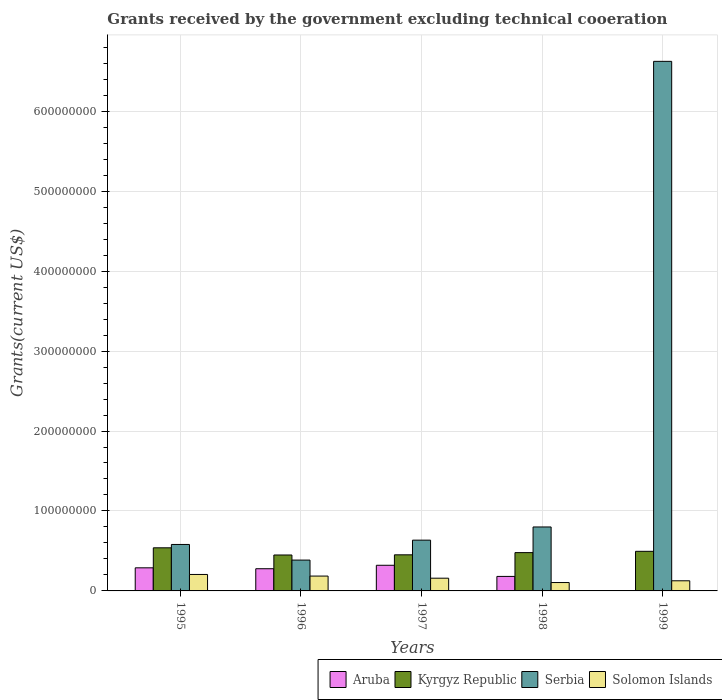How many groups of bars are there?
Offer a terse response. 5. How many bars are there on the 5th tick from the right?
Keep it short and to the point. 4. What is the total grants received by the government in Kyrgyz Republic in 1996?
Your answer should be very brief. 4.49e+07. Across all years, what is the maximum total grants received by the government in Serbia?
Keep it short and to the point. 6.62e+08. Across all years, what is the minimum total grants received by the government in Serbia?
Give a very brief answer. 3.86e+07. In which year was the total grants received by the government in Kyrgyz Republic minimum?
Your answer should be compact. 1996. What is the total total grants received by the government in Serbia in the graph?
Offer a very short reply. 9.03e+08. What is the difference between the total grants received by the government in Solomon Islands in 1995 and that in 1998?
Your answer should be very brief. 1.01e+07. What is the difference between the total grants received by the government in Serbia in 1998 and the total grants received by the government in Kyrgyz Republic in 1999?
Your response must be concise. 3.04e+07. What is the average total grants received by the government in Serbia per year?
Provide a short and direct response. 1.81e+08. In the year 1995, what is the difference between the total grants received by the government in Kyrgyz Republic and total grants received by the government in Solomon Islands?
Your answer should be very brief. 3.33e+07. In how many years, is the total grants received by the government in Aruba greater than 60000000 US$?
Ensure brevity in your answer.  0. What is the ratio of the total grants received by the government in Solomon Islands in 1995 to that in 1996?
Give a very brief answer. 1.11. Is the total grants received by the government in Serbia in 1997 less than that in 1999?
Provide a short and direct response. Yes. Is the difference between the total grants received by the government in Kyrgyz Republic in 1995 and 1996 greater than the difference between the total grants received by the government in Solomon Islands in 1995 and 1996?
Ensure brevity in your answer.  Yes. What is the difference between the highest and the second highest total grants received by the government in Kyrgyz Republic?
Provide a short and direct response. 4.38e+06. What is the difference between the highest and the lowest total grants received by the government in Solomon Islands?
Your response must be concise. 1.01e+07. In how many years, is the total grants received by the government in Solomon Islands greater than the average total grants received by the government in Solomon Islands taken over all years?
Your answer should be very brief. 3. What does the 1st bar from the left in 1998 represents?
Your response must be concise. Aruba. What does the 1st bar from the right in 1996 represents?
Keep it short and to the point. Solomon Islands. What is the difference between two consecutive major ticks on the Y-axis?
Provide a short and direct response. 1.00e+08. How many legend labels are there?
Offer a very short reply. 4. How are the legend labels stacked?
Ensure brevity in your answer.  Horizontal. What is the title of the graph?
Ensure brevity in your answer.  Grants received by the government excluding technical cooeration. What is the label or title of the Y-axis?
Keep it short and to the point. Grants(current US$). What is the Grants(current US$) of Aruba in 1995?
Provide a succinct answer. 2.89e+07. What is the Grants(current US$) of Kyrgyz Republic in 1995?
Provide a short and direct response. 5.39e+07. What is the Grants(current US$) in Serbia in 1995?
Your answer should be very brief. 5.81e+07. What is the Grants(current US$) of Solomon Islands in 1995?
Offer a very short reply. 2.06e+07. What is the Grants(current US$) in Aruba in 1996?
Offer a terse response. 2.78e+07. What is the Grants(current US$) of Kyrgyz Republic in 1996?
Offer a terse response. 4.49e+07. What is the Grants(current US$) in Serbia in 1996?
Keep it short and to the point. 3.86e+07. What is the Grants(current US$) of Solomon Islands in 1996?
Keep it short and to the point. 1.86e+07. What is the Grants(current US$) of Aruba in 1997?
Keep it short and to the point. 3.21e+07. What is the Grants(current US$) in Kyrgyz Republic in 1997?
Provide a short and direct response. 4.52e+07. What is the Grants(current US$) of Serbia in 1997?
Ensure brevity in your answer.  6.35e+07. What is the Grants(current US$) of Solomon Islands in 1997?
Provide a succinct answer. 1.59e+07. What is the Grants(current US$) of Aruba in 1998?
Offer a terse response. 1.81e+07. What is the Grants(current US$) in Kyrgyz Republic in 1998?
Keep it short and to the point. 4.79e+07. What is the Grants(current US$) in Serbia in 1998?
Offer a terse response. 8.00e+07. What is the Grants(current US$) in Solomon Islands in 1998?
Provide a succinct answer. 1.05e+07. What is the Grants(current US$) in Kyrgyz Republic in 1999?
Your answer should be very brief. 4.95e+07. What is the Grants(current US$) of Serbia in 1999?
Your answer should be compact. 6.62e+08. What is the Grants(current US$) in Solomon Islands in 1999?
Provide a short and direct response. 1.27e+07. Across all years, what is the maximum Grants(current US$) of Aruba?
Your answer should be compact. 3.21e+07. Across all years, what is the maximum Grants(current US$) of Kyrgyz Republic?
Make the answer very short. 5.39e+07. Across all years, what is the maximum Grants(current US$) of Serbia?
Your answer should be very brief. 6.62e+08. Across all years, what is the maximum Grants(current US$) of Solomon Islands?
Your answer should be very brief. 2.06e+07. Across all years, what is the minimum Grants(current US$) in Aruba?
Your answer should be very brief. 4.00e+04. Across all years, what is the minimum Grants(current US$) of Kyrgyz Republic?
Provide a short and direct response. 4.49e+07. Across all years, what is the minimum Grants(current US$) of Serbia?
Provide a succinct answer. 3.86e+07. Across all years, what is the minimum Grants(current US$) of Solomon Islands?
Give a very brief answer. 1.05e+07. What is the total Grants(current US$) of Aruba in the graph?
Your answer should be very brief. 1.07e+08. What is the total Grants(current US$) in Kyrgyz Republic in the graph?
Your answer should be very brief. 2.41e+08. What is the total Grants(current US$) in Serbia in the graph?
Give a very brief answer. 9.03e+08. What is the total Grants(current US$) in Solomon Islands in the graph?
Your response must be concise. 7.82e+07. What is the difference between the Grants(current US$) in Aruba in 1995 and that in 1996?
Your response must be concise. 1.14e+06. What is the difference between the Grants(current US$) of Kyrgyz Republic in 1995 and that in 1996?
Provide a succinct answer. 8.99e+06. What is the difference between the Grants(current US$) of Serbia in 1995 and that in 1996?
Your answer should be compact. 1.95e+07. What is the difference between the Grants(current US$) of Solomon Islands in 1995 and that in 1996?
Your response must be concise. 2.02e+06. What is the difference between the Grants(current US$) of Aruba in 1995 and that in 1997?
Provide a short and direct response. -3.18e+06. What is the difference between the Grants(current US$) in Kyrgyz Republic in 1995 and that in 1997?
Offer a terse response. 8.76e+06. What is the difference between the Grants(current US$) in Serbia in 1995 and that in 1997?
Offer a very short reply. -5.40e+06. What is the difference between the Grants(current US$) in Solomon Islands in 1995 and that in 1997?
Ensure brevity in your answer.  4.67e+06. What is the difference between the Grants(current US$) in Aruba in 1995 and that in 1998?
Keep it short and to the point. 1.08e+07. What is the difference between the Grants(current US$) in Kyrgyz Republic in 1995 and that in 1998?
Provide a short and direct response. 6.01e+06. What is the difference between the Grants(current US$) of Serbia in 1995 and that in 1998?
Keep it short and to the point. -2.19e+07. What is the difference between the Grants(current US$) of Solomon Islands in 1995 and that in 1998?
Ensure brevity in your answer.  1.01e+07. What is the difference between the Grants(current US$) of Aruba in 1995 and that in 1999?
Provide a succinct answer. 2.89e+07. What is the difference between the Grants(current US$) of Kyrgyz Republic in 1995 and that in 1999?
Keep it short and to the point. 4.38e+06. What is the difference between the Grants(current US$) in Serbia in 1995 and that in 1999?
Your response must be concise. -6.04e+08. What is the difference between the Grants(current US$) in Solomon Islands in 1995 and that in 1999?
Your response must be concise. 7.91e+06. What is the difference between the Grants(current US$) in Aruba in 1996 and that in 1997?
Provide a succinct answer. -4.32e+06. What is the difference between the Grants(current US$) in Serbia in 1996 and that in 1997?
Give a very brief answer. -2.49e+07. What is the difference between the Grants(current US$) of Solomon Islands in 1996 and that in 1997?
Your response must be concise. 2.65e+06. What is the difference between the Grants(current US$) of Aruba in 1996 and that in 1998?
Give a very brief answer. 9.62e+06. What is the difference between the Grants(current US$) in Kyrgyz Republic in 1996 and that in 1998?
Your answer should be compact. -2.98e+06. What is the difference between the Grants(current US$) of Serbia in 1996 and that in 1998?
Offer a very short reply. -4.14e+07. What is the difference between the Grants(current US$) of Solomon Islands in 1996 and that in 1998?
Keep it short and to the point. 8.08e+06. What is the difference between the Grants(current US$) in Aruba in 1996 and that in 1999?
Ensure brevity in your answer.  2.77e+07. What is the difference between the Grants(current US$) of Kyrgyz Republic in 1996 and that in 1999?
Offer a terse response. -4.61e+06. What is the difference between the Grants(current US$) in Serbia in 1996 and that in 1999?
Make the answer very short. -6.24e+08. What is the difference between the Grants(current US$) of Solomon Islands in 1996 and that in 1999?
Your answer should be compact. 5.89e+06. What is the difference between the Grants(current US$) of Aruba in 1997 and that in 1998?
Your response must be concise. 1.39e+07. What is the difference between the Grants(current US$) in Kyrgyz Republic in 1997 and that in 1998?
Ensure brevity in your answer.  -2.75e+06. What is the difference between the Grants(current US$) of Serbia in 1997 and that in 1998?
Your response must be concise. -1.65e+07. What is the difference between the Grants(current US$) of Solomon Islands in 1997 and that in 1998?
Your answer should be compact. 5.43e+06. What is the difference between the Grants(current US$) in Aruba in 1997 and that in 1999?
Your response must be concise. 3.20e+07. What is the difference between the Grants(current US$) in Kyrgyz Republic in 1997 and that in 1999?
Give a very brief answer. -4.38e+06. What is the difference between the Grants(current US$) of Serbia in 1997 and that in 1999?
Your answer should be compact. -5.99e+08. What is the difference between the Grants(current US$) in Solomon Islands in 1997 and that in 1999?
Make the answer very short. 3.24e+06. What is the difference between the Grants(current US$) of Aruba in 1998 and that in 1999?
Your answer should be compact. 1.81e+07. What is the difference between the Grants(current US$) in Kyrgyz Republic in 1998 and that in 1999?
Your answer should be very brief. -1.63e+06. What is the difference between the Grants(current US$) of Serbia in 1998 and that in 1999?
Provide a short and direct response. -5.82e+08. What is the difference between the Grants(current US$) of Solomon Islands in 1998 and that in 1999?
Provide a short and direct response. -2.19e+06. What is the difference between the Grants(current US$) of Aruba in 1995 and the Grants(current US$) of Kyrgyz Republic in 1996?
Give a very brief answer. -1.60e+07. What is the difference between the Grants(current US$) in Aruba in 1995 and the Grants(current US$) in Serbia in 1996?
Ensure brevity in your answer.  -9.67e+06. What is the difference between the Grants(current US$) in Aruba in 1995 and the Grants(current US$) in Solomon Islands in 1996?
Your answer should be very brief. 1.03e+07. What is the difference between the Grants(current US$) of Kyrgyz Republic in 1995 and the Grants(current US$) of Serbia in 1996?
Give a very brief answer. 1.54e+07. What is the difference between the Grants(current US$) in Kyrgyz Republic in 1995 and the Grants(current US$) in Solomon Islands in 1996?
Provide a short and direct response. 3.54e+07. What is the difference between the Grants(current US$) of Serbia in 1995 and the Grants(current US$) of Solomon Islands in 1996?
Your answer should be very brief. 3.95e+07. What is the difference between the Grants(current US$) of Aruba in 1995 and the Grants(current US$) of Kyrgyz Republic in 1997?
Make the answer very short. -1.63e+07. What is the difference between the Grants(current US$) in Aruba in 1995 and the Grants(current US$) in Serbia in 1997?
Offer a very short reply. -3.46e+07. What is the difference between the Grants(current US$) of Aruba in 1995 and the Grants(current US$) of Solomon Islands in 1997?
Offer a very short reply. 1.30e+07. What is the difference between the Grants(current US$) of Kyrgyz Republic in 1995 and the Grants(current US$) of Serbia in 1997?
Give a very brief answer. -9.58e+06. What is the difference between the Grants(current US$) of Kyrgyz Republic in 1995 and the Grants(current US$) of Solomon Islands in 1997?
Offer a very short reply. 3.80e+07. What is the difference between the Grants(current US$) of Serbia in 1995 and the Grants(current US$) of Solomon Islands in 1997?
Ensure brevity in your answer.  4.22e+07. What is the difference between the Grants(current US$) of Aruba in 1995 and the Grants(current US$) of Kyrgyz Republic in 1998?
Your answer should be compact. -1.90e+07. What is the difference between the Grants(current US$) in Aruba in 1995 and the Grants(current US$) in Serbia in 1998?
Ensure brevity in your answer.  -5.11e+07. What is the difference between the Grants(current US$) of Aruba in 1995 and the Grants(current US$) of Solomon Islands in 1998?
Offer a very short reply. 1.84e+07. What is the difference between the Grants(current US$) in Kyrgyz Republic in 1995 and the Grants(current US$) in Serbia in 1998?
Make the answer very short. -2.61e+07. What is the difference between the Grants(current US$) in Kyrgyz Republic in 1995 and the Grants(current US$) in Solomon Islands in 1998?
Offer a very short reply. 4.34e+07. What is the difference between the Grants(current US$) in Serbia in 1995 and the Grants(current US$) in Solomon Islands in 1998?
Make the answer very short. 4.76e+07. What is the difference between the Grants(current US$) in Aruba in 1995 and the Grants(current US$) in Kyrgyz Republic in 1999?
Your answer should be very brief. -2.06e+07. What is the difference between the Grants(current US$) in Aruba in 1995 and the Grants(current US$) in Serbia in 1999?
Provide a short and direct response. -6.33e+08. What is the difference between the Grants(current US$) in Aruba in 1995 and the Grants(current US$) in Solomon Islands in 1999?
Ensure brevity in your answer.  1.62e+07. What is the difference between the Grants(current US$) in Kyrgyz Republic in 1995 and the Grants(current US$) in Serbia in 1999?
Provide a succinct answer. -6.08e+08. What is the difference between the Grants(current US$) of Kyrgyz Republic in 1995 and the Grants(current US$) of Solomon Islands in 1999?
Your answer should be compact. 4.12e+07. What is the difference between the Grants(current US$) in Serbia in 1995 and the Grants(current US$) in Solomon Islands in 1999?
Give a very brief answer. 4.54e+07. What is the difference between the Grants(current US$) of Aruba in 1996 and the Grants(current US$) of Kyrgyz Republic in 1997?
Provide a short and direct response. -1.74e+07. What is the difference between the Grants(current US$) in Aruba in 1996 and the Grants(current US$) in Serbia in 1997?
Your answer should be very brief. -3.57e+07. What is the difference between the Grants(current US$) of Aruba in 1996 and the Grants(current US$) of Solomon Islands in 1997?
Your answer should be very brief. 1.18e+07. What is the difference between the Grants(current US$) of Kyrgyz Republic in 1996 and the Grants(current US$) of Serbia in 1997?
Offer a very short reply. -1.86e+07. What is the difference between the Grants(current US$) in Kyrgyz Republic in 1996 and the Grants(current US$) in Solomon Islands in 1997?
Provide a short and direct response. 2.90e+07. What is the difference between the Grants(current US$) in Serbia in 1996 and the Grants(current US$) in Solomon Islands in 1997?
Keep it short and to the point. 2.26e+07. What is the difference between the Grants(current US$) in Aruba in 1996 and the Grants(current US$) in Kyrgyz Republic in 1998?
Your answer should be compact. -2.02e+07. What is the difference between the Grants(current US$) of Aruba in 1996 and the Grants(current US$) of Serbia in 1998?
Your response must be concise. -5.22e+07. What is the difference between the Grants(current US$) of Aruba in 1996 and the Grants(current US$) of Solomon Islands in 1998?
Your answer should be compact. 1.73e+07. What is the difference between the Grants(current US$) in Kyrgyz Republic in 1996 and the Grants(current US$) in Serbia in 1998?
Your response must be concise. -3.51e+07. What is the difference between the Grants(current US$) of Kyrgyz Republic in 1996 and the Grants(current US$) of Solomon Islands in 1998?
Your response must be concise. 3.44e+07. What is the difference between the Grants(current US$) in Serbia in 1996 and the Grants(current US$) in Solomon Islands in 1998?
Provide a short and direct response. 2.81e+07. What is the difference between the Grants(current US$) of Aruba in 1996 and the Grants(current US$) of Kyrgyz Republic in 1999?
Your answer should be compact. -2.18e+07. What is the difference between the Grants(current US$) of Aruba in 1996 and the Grants(current US$) of Serbia in 1999?
Provide a short and direct response. -6.35e+08. What is the difference between the Grants(current US$) in Aruba in 1996 and the Grants(current US$) in Solomon Islands in 1999?
Offer a terse response. 1.51e+07. What is the difference between the Grants(current US$) of Kyrgyz Republic in 1996 and the Grants(current US$) of Serbia in 1999?
Offer a terse response. -6.17e+08. What is the difference between the Grants(current US$) in Kyrgyz Republic in 1996 and the Grants(current US$) in Solomon Islands in 1999?
Your answer should be compact. 3.22e+07. What is the difference between the Grants(current US$) of Serbia in 1996 and the Grants(current US$) of Solomon Islands in 1999?
Give a very brief answer. 2.59e+07. What is the difference between the Grants(current US$) in Aruba in 1997 and the Grants(current US$) in Kyrgyz Republic in 1998?
Your answer should be compact. -1.58e+07. What is the difference between the Grants(current US$) in Aruba in 1997 and the Grants(current US$) in Serbia in 1998?
Provide a succinct answer. -4.79e+07. What is the difference between the Grants(current US$) of Aruba in 1997 and the Grants(current US$) of Solomon Islands in 1998?
Offer a terse response. 2.16e+07. What is the difference between the Grants(current US$) of Kyrgyz Republic in 1997 and the Grants(current US$) of Serbia in 1998?
Offer a very short reply. -3.48e+07. What is the difference between the Grants(current US$) in Kyrgyz Republic in 1997 and the Grants(current US$) in Solomon Islands in 1998?
Offer a very short reply. 3.47e+07. What is the difference between the Grants(current US$) in Serbia in 1997 and the Grants(current US$) in Solomon Islands in 1998?
Make the answer very short. 5.30e+07. What is the difference between the Grants(current US$) in Aruba in 1997 and the Grants(current US$) in Kyrgyz Republic in 1999?
Keep it short and to the point. -1.75e+07. What is the difference between the Grants(current US$) of Aruba in 1997 and the Grants(current US$) of Serbia in 1999?
Offer a terse response. -6.30e+08. What is the difference between the Grants(current US$) in Aruba in 1997 and the Grants(current US$) in Solomon Islands in 1999?
Offer a very short reply. 1.94e+07. What is the difference between the Grants(current US$) of Kyrgyz Republic in 1997 and the Grants(current US$) of Serbia in 1999?
Give a very brief answer. -6.17e+08. What is the difference between the Grants(current US$) in Kyrgyz Republic in 1997 and the Grants(current US$) in Solomon Islands in 1999?
Your answer should be compact. 3.25e+07. What is the difference between the Grants(current US$) in Serbia in 1997 and the Grants(current US$) in Solomon Islands in 1999?
Your answer should be very brief. 5.08e+07. What is the difference between the Grants(current US$) in Aruba in 1998 and the Grants(current US$) in Kyrgyz Republic in 1999?
Offer a very short reply. -3.14e+07. What is the difference between the Grants(current US$) in Aruba in 1998 and the Grants(current US$) in Serbia in 1999?
Keep it short and to the point. -6.44e+08. What is the difference between the Grants(current US$) of Aruba in 1998 and the Grants(current US$) of Solomon Islands in 1999?
Make the answer very short. 5.46e+06. What is the difference between the Grants(current US$) of Kyrgyz Republic in 1998 and the Grants(current US$) of Serbia in 1999?
Provide a short and direct response. -6.14e+08. What is the difference between the Grants(current US$) in Kyrgyz Republic in 1998 and the Grants(current US$) in Solomon Islands in 1999?
Ensure brevity in your answer.  3.52e+07. What is the difference between the Grants(current US$) of Serbia in 1998 and the Grants(current US$) of Solomon Islands in 1999?
Offer a very short reply. 6.73e+07. What is the average Grants(current US$) of Aruba per year?
Your answer should be compact. 2.14e+07. What is the average Grants(current US$) in Kyrgyz Republic per year?
Make the answer very short. 4.83e+07. What is the average Grants(current US$) in Serbia per year?
Provide a short and direct response. 1.81e+08. What is the average Grants(current US$) of Solomon Islands per year?
Provide a succinct answer. 1.56e+07. In the year 1995, what is the difference between the Grants(current US$) of Aruba and Grants(current US$) of Kyrgyz Republic?
Your response must be concise. -2.50e+07. In the year 1995, what is the difference between the Grants(current US$) in Aruba and Grants(current US$) in Serbia?
Your answer should be very brief. -2.92e+07. In the year 1995, what is the difference between the Grants(current US$) in Aruba and Grants(current US$) in Solomon Islands?
Offer a very short reply. 8.31e+06. In the year 1995, what is the difference between the Grants(current US$) in Kyrgyz Republic and Grants(current US$) in Serbia?
Offer a terse response. -4.18e+06. In the year 1995, what is the difference between the Grants(current US$) of Kyrgyz Republic and Grants(current US$) of Solomon Islands?
Provide a short and direct response. 3.33e+07. In the year 1995, what is the difference between the Grants(current US$) of Serbia and Grants(current US$) of Solomon Islands?
Make the answer very short. 3.75e+07. In the year 1996, what is the difference between the Grants(current US$) of Aruba and Grants(current US$) of Kyrgyz Republic?
Your response must be concise. -1.72e+07. In the year 1996, what is the difference between the Grants(current US$) of Aruba and Grants(current US$) of Serbia?
Give a very brief answer. -1.08e+07. In the year 1996, what is the difference between the Grants(current US$) in Aruba and Grants(current US$) in Solomon Islands?
Your response must be concise. 9.19e+06. In the year 1996, what is the difference between the Grants(current US$) of Kyrgyz Republic and Grants(current US$) of Serbia?
Provide a succinct answer. 6.36e+06. In the year 1996, what is the difference between the Grants(current US$) of Kyrgyz Republic and Grants(current US$) of Solomon Islands?
Offer a terse response. 2.64e+07. In the year 1996, what is the difference between the Grants(current US$) of Serbia and Grants(current US$) of Solomon Islands?
Give a very brief answer. 2.00e+07. In the year 1997, what is the difference between the Grants(current US$) in Aruba and Grants(current US$) in Kyrgyz Republic?
Offer a very short reply. -1.31e+07. In the year 1997, what is the difference between the Grants(current US$) in Aruba and Grants(current US$) in Serbia?
Your answer should be compact. -3.14e+07. In the year 1997, what is the difference between the Grants(current US$) in Aruba and Grants(current US$) in Solomon Islands?
Your answer should be very brief. 1.62e+07. In the year 1997, what is the difference between the Grants(current US$) in Kyrgyz Republic and Grants(current US$) in Serbia?
Provide a short and direct response. -1.83e+07. In the year 1997, what is the difference between the Grants(current US$) of Kyrgyz Republic and Grants(current US$) of Solomon Islands?
Make the answer very short. 2.92e+07. In the year 1997, what is the difference between the Grants(current US$) in Serbia and Grants(current US$) in Solomon Islands?
Offer a terse response. 4.76e+07. In the year 1998, what is the difference between the Grants(current US$) of Aruba and Grants(current US$) of Kyrgyz Republic?
Ensure brevity in your answer.  -2.98e+07. In the year 1998, what is the difference between the Grants(current US$) in Aruba and Grants(current US$) in Serbia?
Keep it short and to the point. -6.18e+07. In the year 1998, what is the difference between the Grants(current US$) of Aruba and Grants(current US$) of Solomon Islands?
Your answer should be compact. 7.65e+06. In the year 1998, what is the difference between the Grants(current US$) of Kyrgyz Republic and Grants(current US$) of Serbia?
Your answer should be compact. -3.21e+07. In the year 1998, what is the difference between the Grants(current US$) in Kyrgyz Republic and Grants(current US$) in Solomon Islands?
Your answer should be compact. 3.74e+07. In the year 1998, what is the difference between the Grants(current US$) of Serbia and Grants(current US$) of Solomon Islands?
Ensure brevity in your answer.  6.95e+07. In the year 1999, what is the difference between the Grants(current US$) of Aruba and Grants(current US$) of Kyrgyz Republic?
Offer a very short reply. -4.95e+07. In the year 1999, what is the difference between the Grants(current US$) in Aruba and Grants(current US$) in Serbia?
Offer a terse response. -6.62e+08. In the year 1999, what is the difference between the Grants(current US$) of Aruba and Grants(current US$) of Solomon Islands?
Offer a terse response. -1.26e+07. In the year 1999, what is the difference between the Grants(current US$) of Kyrgyz Republic and Grants(current US$) of Serbia?
Ensure brevity in your answer.  -6.13e+08. In the year 1999, what is the difference between the Grants(current US$) of Kyrgyz Republic and Grants(current US$) of Solomon Islands?
Ensure brevity in your answer.  3.69e+07. In the year 1999, what is the difference between the Grants(current US$) of Serbia and Grants(current US$) of Solomon Islands?
Your response must be concise. 6.50e+08. What is the ratio of the Grants(current US$) of Aruba in 1995 to that in 1996?
Offer a terse response. 1.04. What is the ratio of the Grants(current US$) of Kyrgyz Republic in 1995 to that in 1996?
Your answer should be very brief. 1.2. What is the ratio of the Grants(current US$) in Serbia in 1995 to that in 1996?
Make the answer very short. 1.51. What is the ratio of the Grants(current US$) of Solomon Islands in 1995 to that in 1996?
Ensure brevity in your answer.  1.11. What is the ratio of the Grants(current US$) of Aruba in 1995 to that in 1997?
Give a very brief answer. 0.9. What is the ratio of the Grants(current US$) in Kyrgyz Republic in 1995 to that in 1997?
Ensure brevity in your answer.  1.19. What is the ratio of the Grants(current US$) of Serbia in 1995 to that in 1997?
Your answer should be compact. 0.92. What is the ratio of the Grants(current US$) of Solomon Islands in 1995 to that in 1997?
Your response must be concise. 1.29. What is the ratio of the Grants(current US$) in Aruba in 1995 to that in 1998?
Your answer should be compact. 1.59. What is the ratio of the Grants(current US$) of Kyrgyz Republic in 1995 to that in 1998?
Provide a short and direct response. 1.13. What is the ratio of the Grants(current US$) of Serbia in 1995 to that in 1998?
Ensure brevity in your answer.  0.73. What is the ratio of the Grants(current US$) in Solomon Islands in 1995 to that in 1998?
Your answer should be very brief. 1.96. What is the ratio of the Grants(current US$) of Aruba in 1995 to that in 1999?
Ensure brevity in your answer.  722.5. What is the ratio of the Grants(current US$) of Kyrgyz Republic in 1995 to that in 1999?
Provide a succinct answer. 1.09. What is the ratio of the Grants(current US$) of Serbia in 1995 to that in 1999?
Provide a short and direct response. 0.09. What is the ratio of the Grants(current US$) of Solomon Islands in 1995 to that in 1999?
Your answer should be very brief. 1.62. What is the ratio of the Grants(current US$) of Aruba in 1996 to that in 1997?
Provide a short and direct response. 0.87. What is the ratio of the Grants(current US$) of Kyrgyz Republic in 1996 to that in 1997?
Keep it short and to the point. 0.99. What is the ratio of the Grants(current US$) in Serbia in 1996 to that in 1997?
Provide a short and direct response. 0.61. What is the ratio of the Grants(current US$) in Solomon Islands in 1996 to that in 1997?
Offer a terse response. 1.17. What is the ratio of the Grants(current US$) of Aruba in 1996 to that in 1998?
Provide a short and direct response. 1.53. What is the ratio of the Grants(current US$) in Kyrgyz Republic in 1996 to that in 1998?
Your answer should be very brief. 0.94. What is the ratio of the Grants(current US$) of Serbia in 1996 to that in 1998?
Keep it short and to the point. 0.48. What is the ratio of the Grants(current US$) of Solomon Islands in 1996 to that in 1998?
Provide a succinct answer. 1.77. What is the ratio of the Grants(current US$) of Aruba in 1996 to that in 1999?
Your response must be concise. 694. What is the ratio of the Grants(current US$) of Kyrgyz Republic in 1996 to that in 1999?
Your answer should be compact. 0.91. What is the ratio of the Grants(current US$) in Serbia in 1996 to that in 1999?
Give a very brief answer. 0.06. What is the ratio of the Grants(current US$) in Solomon Islands in 1996 to that in 1999?
Your answer should be very brief. 1.46. What is the ratio of the Grants(current US$) of Aruba in 1997 to that in 1998?
Ensure brevity in your answer.  1.77. What is the ratio of the Grants(current US$) in Kyrgyz Republic in 1997 to that in 1998?
Your response must be concise. 0.94. What is the ratio of the Grants(current US$) in Serbia in 1997 to that in 1998?
Offer a terse response. 0.79. What is the ratio of the Grants(current US$) of Solomon Islands in 1997 to that in 1998?
Your response must be concise. 1.52. What is the ratio of the Grants(current US$) in Aruba in 1997 to that in 1999?
Provide a short and direct response. 802. What is the ratio of the Grants(current US$) of Kyrgyz Republic in 1997 to that in 1999?
Give a very brief answer. 0.91. What is the ratio of the Grants(current US$) in Serbia in 1997 to that in 1999?
Make the answer very short. 0.1. What is the ratio of the Grants(current US$) of Solomon Islands in 1997 to that in 1999?
Your response must be concise. 1.26. What is the ratio of the Grants(current US$) in Aruba in 1998 to that in 1999?
Your response must be concise. 453.5. What is the ratio of the Grants(current US$) of Kyrgyz Republic in 1998 to that in 1999?
Offer a terse response. 0.97. What is the ratio of the Grants(current US$) of Serbia in 1998 to that in 1999?
Make the answer very short. 0.12. What is the ratio of the Grants(current US$) of Solomon Islands in 1998 to that in 1999?
Your answer should be compact. 0.83. What is the difference between the highest and the second highest Grants(current US$) in Aruba?
Keep it short and to the point. 3.18e+06. What is the difference between the highest and the second highest Grants(current US$) in Kyrgyz Republic?
Your response must be concise. 4.38e+06. What is the difference between the highest and the second highest Grants(current US$) of Serbia?
Your answer should be very brief. 5.82e+08. What is the difference between the highest and the second highest Grants(current US$) of Solomon Islands?
Your answer should be very brief. 2.02e+06. What is the difference between the highest and the lowest Grants(current US$) of Aruba?
Your response must be concise. 3.20e+07. What is the difference between the highest and the lowest Grants(current US$) of Kyrgyz Republic?
Your answer should be compact. 8.99e+06. What is the difference between the highest and the lowest Grants(current US$) of Serbia?
Provide a short and direct response. 6.24e+08. What is the difference between the highest and the lowest Grants(current US$) of Solomon Islands?
Offer a very short reply. 1.01e+07. 